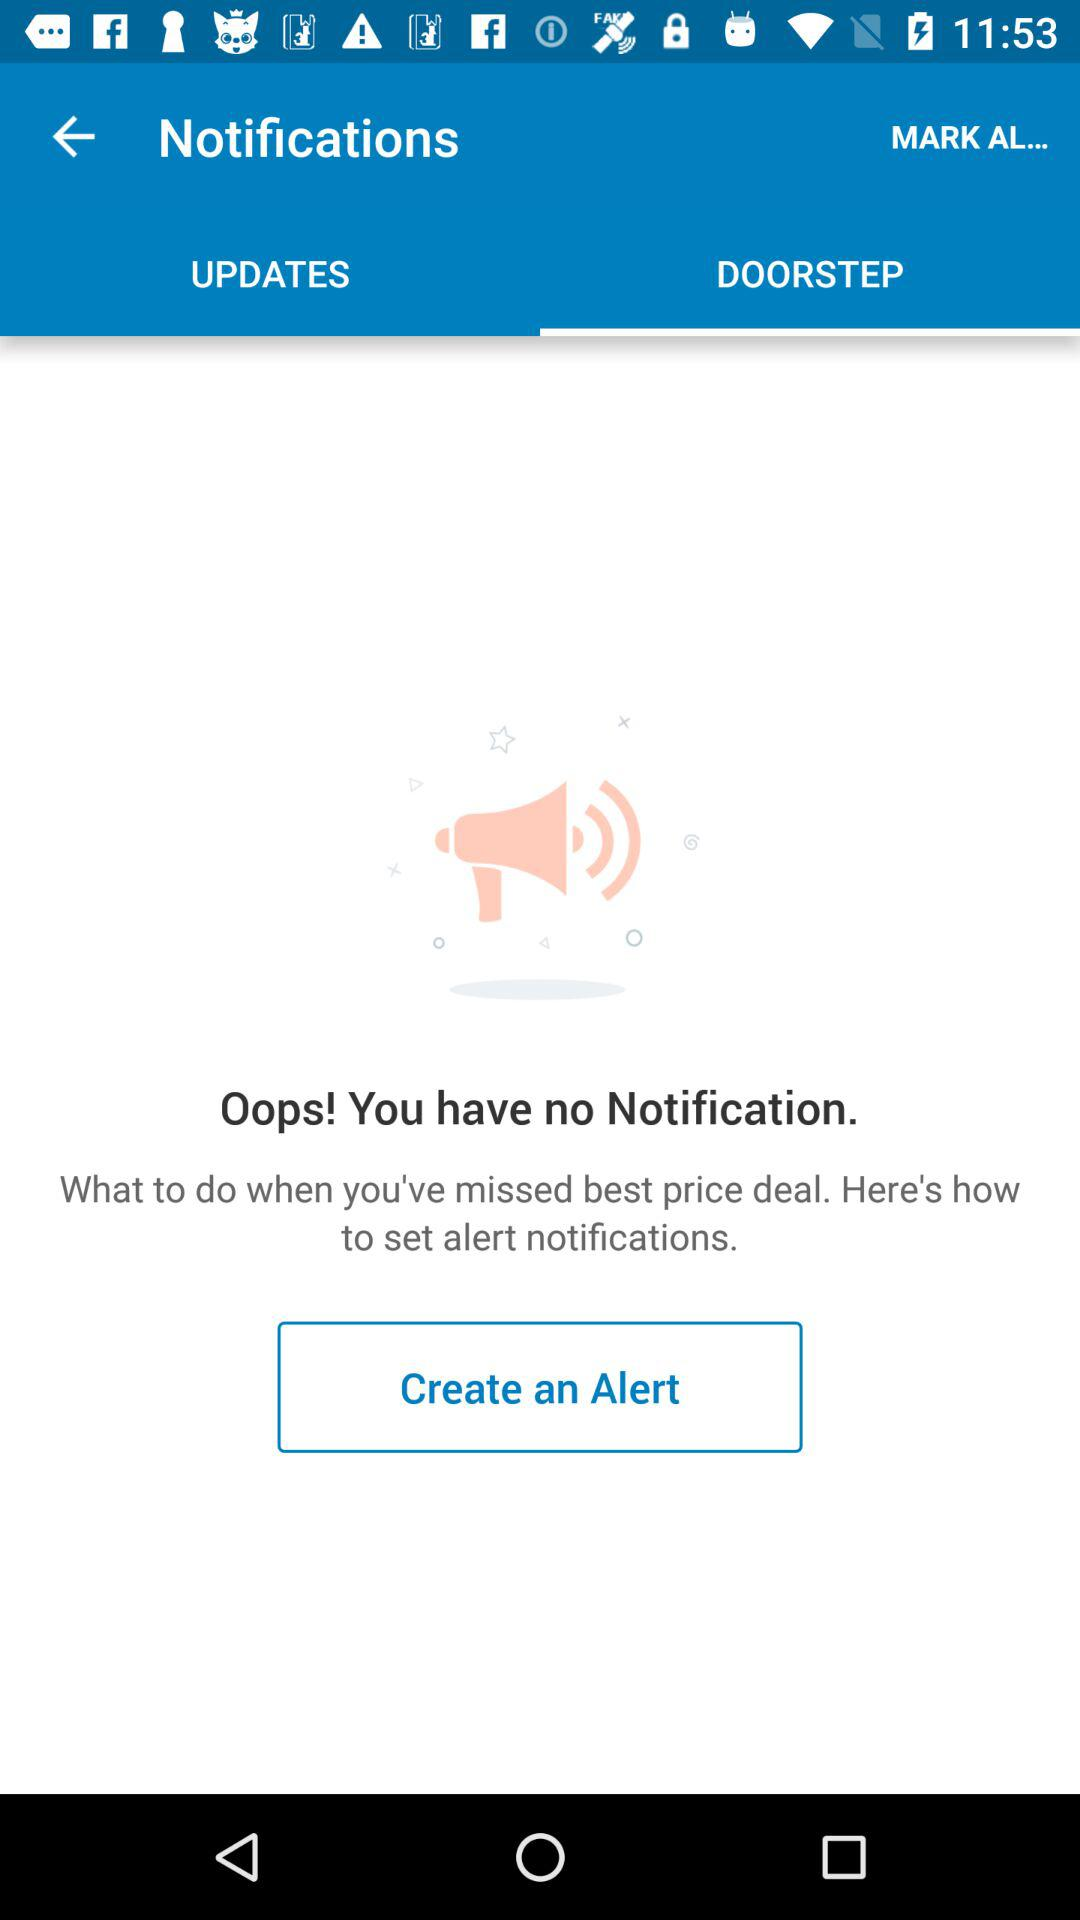Which tab is selected? The selected tab is "DOORSTEP". 